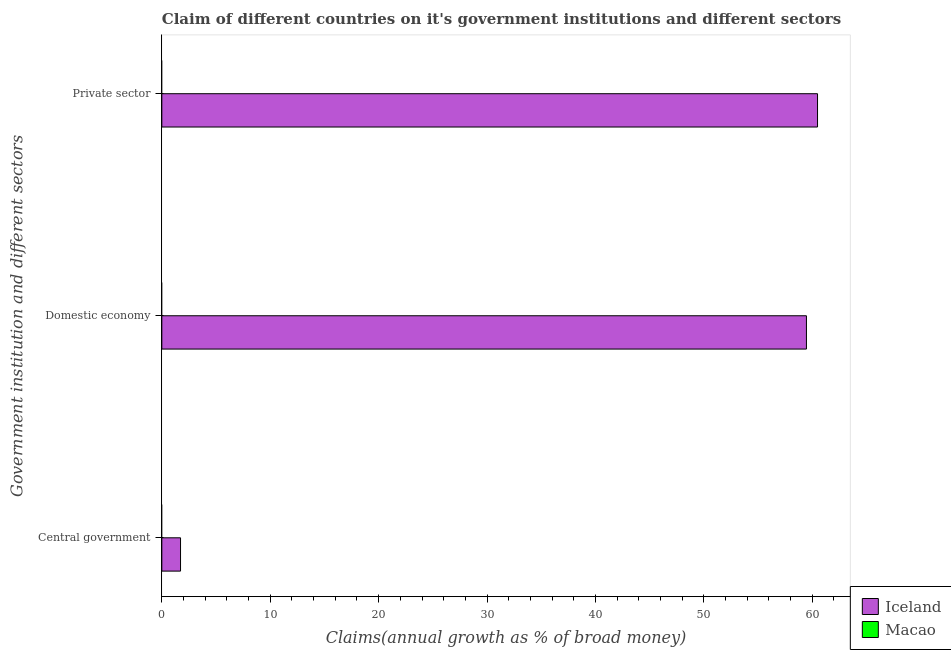Are the number of bars per tick equal to the number of legend labels?
Provide a succinct answer. No. Are the number of bars on each tick of the Y-axis equal?
Ensure brevity in your answer.  Yes. What is the label of the 1st group of bars from the top?
Your answer should be very brief. Private sector. Across all countries, what is the maximum percentage of claim on the private sector?
Your answer should be compact. 60.49. In which country was the percentage of claim on the domestic economy maximum?
Ensure brevity in your answer.  Iceland. What is the total percentage of claim on the domestic economy in the graph?
Your answer should be very brief. 59.47. What is the difference between the percentage of claim on the private sector in Macao and the percentage of claim on the central government in Iceland?
Offer a very short reply. -1.73. What is the average percentage of claim on the private sector per country?
Provide a short and direct response. 30.24. What is the difference between the percentage of claim on the domestic economy and percentage of claim on the private sector in Iceland?
Provide a succinct answer. -1.02. What is the difference between the highest and the lowest percentage of claim on the private sector?
Your answer should be compact. 60.49. How many bars are there?
Provide a short and direct response. 3. Are all the bars in the graph horizontal?
Make the answer very short. Yes. Are the values on the major ticks of X-axis written in scientific E-notation?
Give a very brief answer. No. Does the graph contain grids?
Your answer should be very brief. No. Where does the legend appear in the graph?
Your answer should be very brief. Bottom right. How are the legend labels stacked?
Ensure brevity in your answer.  Vertical. What is the title of the graph?
Offer a very short reply. Claim of different countries on it's government institutions and different sectors. Does "Madagascar" appear as one of the legend labels in the graph?
Provide a short and direct response. No. What is the label or title of the X-axis?
Your response must be concise. Claims(annual growth as % of broad money). What is the label or title of the Y-axis?
Keep it short and to the point. Government institution and different sectors. What is the Claims(annual growth as % of broad money) in Iceland in Central government?
Your answer should be very brief. 1.73. What is the Claims(annual growth as % of broad money) in Macao in Central government?
Offer a very short reply. 0. What is the Claims(annual growth as % of broad money) in Iceland in Domestic economy?
Keep it short and to the point. 59.47. What is the Claims(annual growth as % of broad money) in Iceland in Private sector?
Offer a terse response. 60.49. Across all Government institution and different sectors, what is the maximum Claims(annual growth as % of broad money) in Iceland?
Give a very brief answer. 60.49. Across all Government institution and different sectors, what is the minimum Claims(annual growth as % of broad money) of Iceland?
Offer a very short reply. 1.73. What is the total Claims(annual growth as % of broad money) in Iceland in the graph?
Give a very brief answer. 121.68. What is the total Claims(annual growth as % of broad money) in Macao in the graph?
Offer a very short reply. 0. What is the difference between the Claims(annual growth as % of broad money) of Iceland in Central government and that in Domestic economy?
Offer a terse response. -57.74. What is the difference between the Claims(annual growth as % of broad money) in Iceland in Central government and that in Private sector?
Make the answer very short. -58.76. What is the difference between the Claims(annual growth as % of broad money) in Iceland in Domestic economy and that in Private sector?
Ensure brevity in your answer.  -1.02. What is the average Claims(annual growth as % of broad money) of Iceland per Government institution and different sectors?
Your response must be concise. 40.56. What is the average Claims(annual growth as % of broad money) in Macao per Government institution and different sectors?
Provide a succinct answer. 0. What is the ratio of the Claims(annual growth as % of broad money) in Iceland in Central government to that in Domestic economy?
Make the answer very short. 0.03. What is the ratio of the Claims(annual growth as % of broad money) in Iceland in Central government to that in Private sector?
Make the answer very short. 0.03. What is the ratio of the Claims(annual growth as % of broad money) of Iceland in Domestic economy to that in Private sector?
Your response must be concise. 0.98. What is the difference between the highest and the second highest Claims(annual growth as % of broad money) of Iceland?
Offer a very short reply. 1.02. What is the difference between the highest and the lowest Claims(annual growth as % of broad money) of Iceland?
Provide a short and direct response. 58.76. 